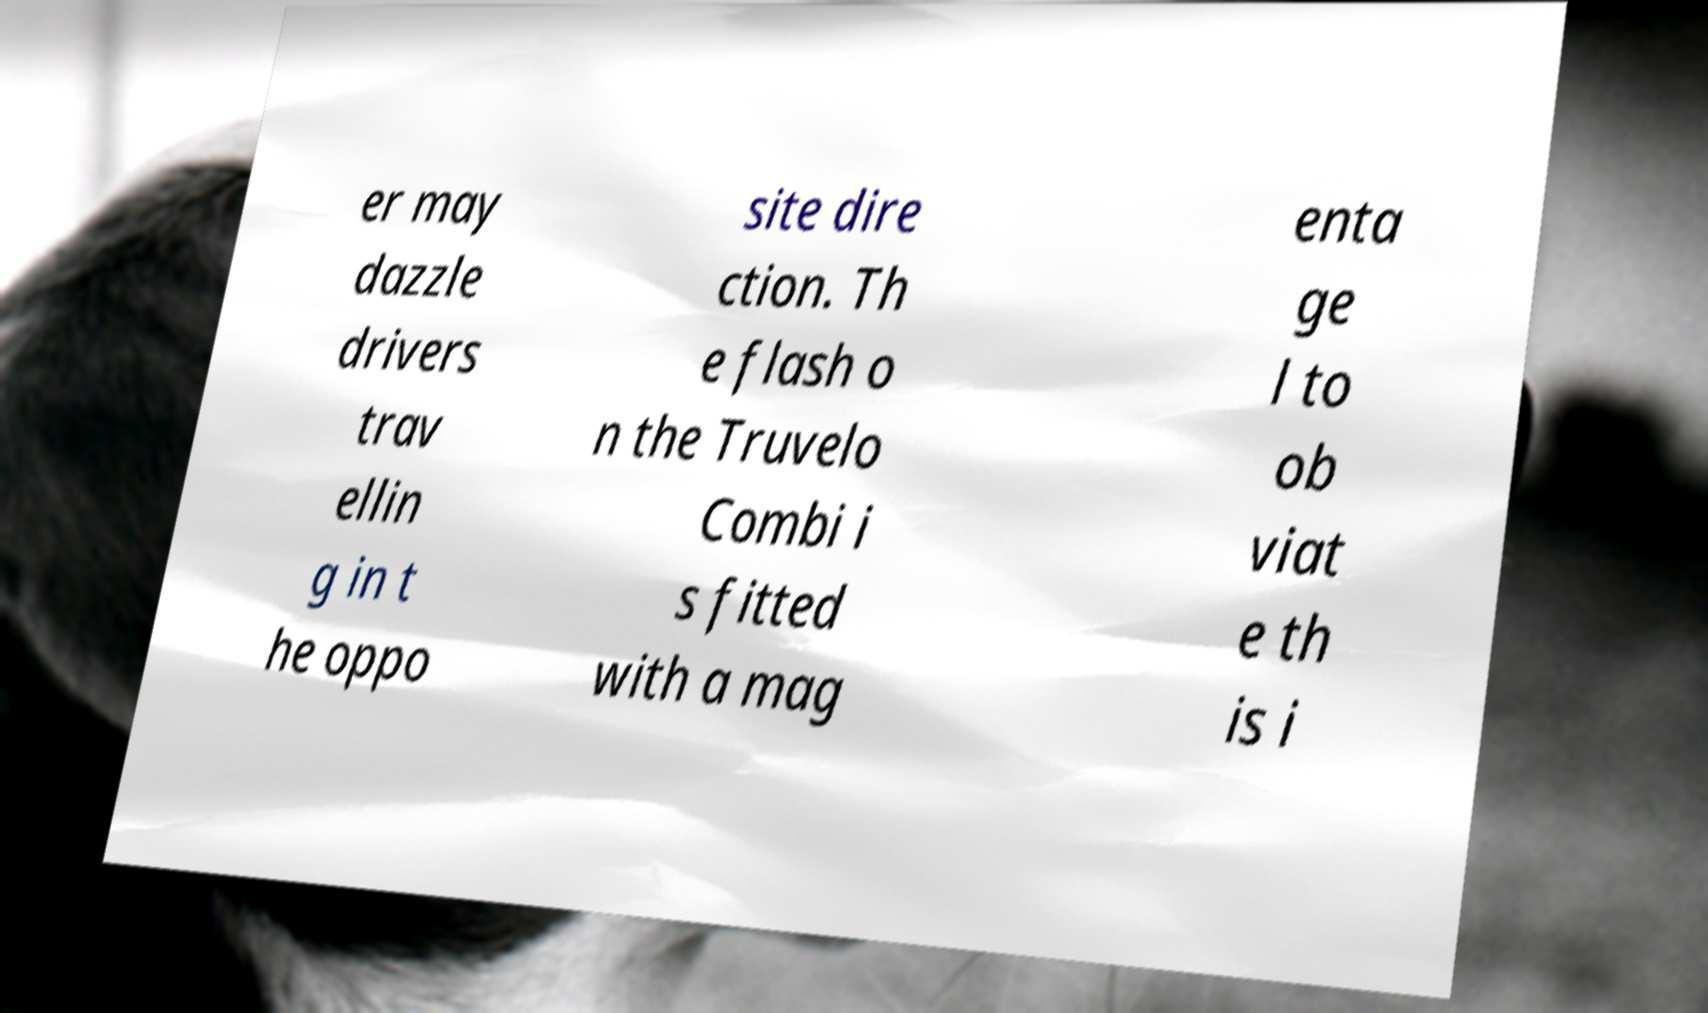Can you accurately transcribe the text from the provided image for me? er may dazzle drivers trav ellin g in t he oppo site dire ction. Th e flash o n the Truvelo Combi i s fitted with a mag enta ge l to ob viat e th is i 